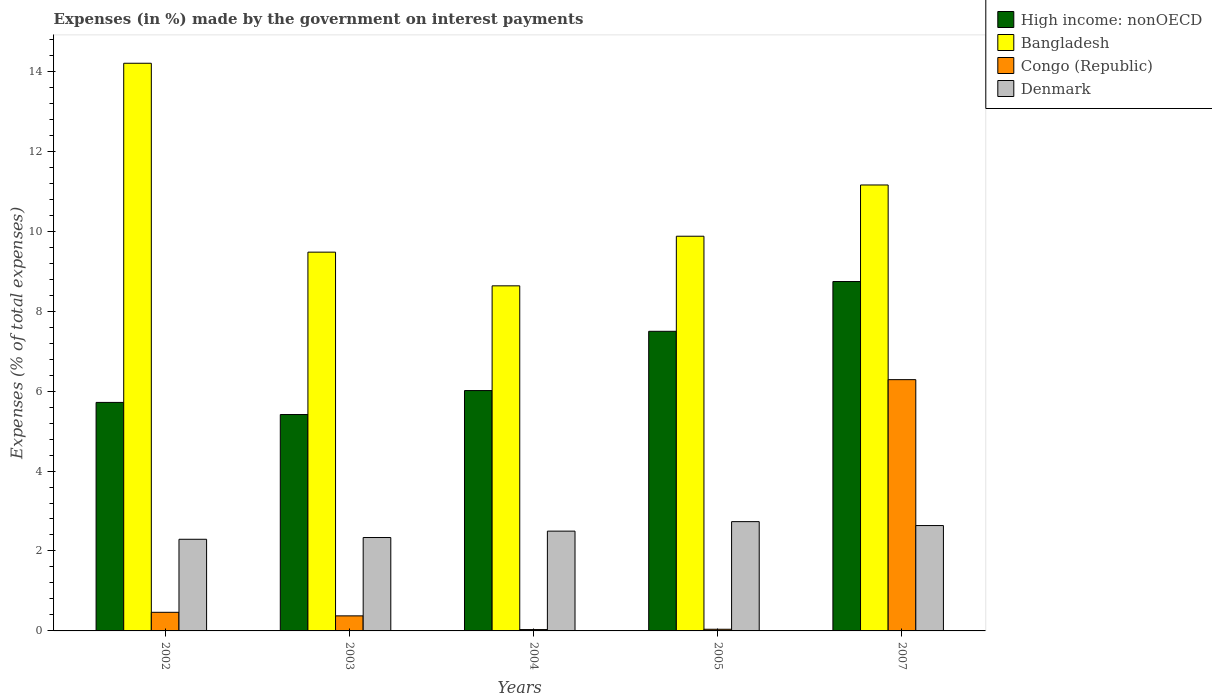How many different coloured bars are there?
Offer a terse response. 4. Are the number of bars on each tick of the X-axis equal?
Ensure brevity in your answer.  Yes. How many bars are there on the 3rd tick from the left?
Keep it short and to the point. 4. In how many cases, is the number of bars for a given year not equal to the number of legend labels?
Offer a terse response. 0. What is the percentage of expenses made by the government on interest payments in Bangladesh in 2007?
Offer a very short reply. 11.16. Across all years, what is the maximum percentage of expenses made by the government on interest payments in Denmark?
Keep it short and to the point. 2.73. Across all years, what is the minimum percentage of expenses made by the government on interest payments in Congo (Republic)?
Keep it short and to the point. 0.03. In which year was the percentage of expenses made by the government on interest payments in Congo (Republic) minimum?
Provide a succinct answer. 2004. What is the total percentage of expenses made by the government on interest payments in Bangladesh in the graph?
Keep it short and to the point. 53.34. What is the difference between the percentage of expenses made by the government on interest payments in High income: nonOECD in 2003 and that in 2007?
Make the answer very short. -3.33. What is the difference between the percentage of expenses made by the government on interest payments in Denmark in 2007 and the percentage of expenses made by the government on interest payments in High income: nonOECD in 2004?
Your answer should be compact. -3.38. What is the average percentage of expenses made by the government on interest payments in Bangladesh per year?
Give a very brief answer. 10.67. In the year 2005, what is the difference between the percentage of expenses made by the government on interest payments in Denmark and percentage of expenses made by the government on interest payments in Bangladesh?
Give a very brief answer. -7.14. What is the ratio of the percentage of expenses made by the government on interest payments in High income: nonOECD in 2004 to that in 2005?
Offer a very short reply. 0.8. Is the percentage of expenses made by the government on interest payments in High income: nonOECD in 2002 less than that in 2005?
Ensure brevity in your answer.  Yes. Is the difference between the percentage of expenses made by the government on interest payments in Denmark in 2005 and 2007 greater than the difference between the percentage of expenses made by the government on interest payments in Bangladesh in 2005 and 2007?
Provide a succinct answer. Yes. What is the difference between the highest and the second highest percentage of expenses made by the government on interest payments in Congo (Republic)?
Give a very brief answer. 5.82. What is the difference between the highest and the lowest percentage of expenses made by the government on interest payments in Denmark?
Ensure brevity in your answer.  0.44. In how many years, is the percentage of expenses made by the government on interest payments in Denmark greater than the average percentage of expenses made by the government on interest payments in Denmark taken over all years?
Offer a very short reply. 2. Is the sum of the percentage of expenses made by the government on interest payments in Bangladesh in 2002 and 2007 greater than the maximum percentage of expenses made by the government on interest payments in Denmark across all years?
Provide a short and direct response. Yes. What does the 3rd bar from the left in 2004 represents?
Offer a terse response. Congo (Republic). What does the 4th bar from the right in 2002 represents?
Your answer should be very brief. High income: nonOECD. What is the difference between two consecutive major ticks on the Y-axis?
Offer a very short reply. 2. Does the graph contain any zero values?
Give a very brief answer. No. Does the graph contain grids?
Your answer should be very brief. No. What is the title of the graph?
Offer a terse response. Expenses (in %) made by the government on interest payments. What is the label or title of the X-axis?
Give a very brief answer. Years. What is the label or title of the Y-axis?
Your response must be concise. Expenses (% of total expenses). What is the Expenses (% of total expenses) of High income: nonOECD in 2002?
Make the answer very short. 5.72. What is the Expenses (% of total expenses) in Bangladesh in 2002?
Keep it short and to the point. 14.2. What is the Expenses (% of total expenses) of Congo (Republic) in 2002?
Provide a short and direct response. 0.47. What is the Expenses (% of total expenses) in Denmark in 2002?
Provide a short and direct response. 2.29. What is the Expenses (% of total expenses) in High income: nonOECD in 2003?
Your response must be concise. 5.41. What is the Expenses (% of total expenses) of Bangladesh in 2003?
Offer a terse response. 9.48. What is the Expenses (% of total expenses) of Congo (Republic) in 2003?
Make the answer very short. 0.38. What is the Expenses (% of total expenses) in Denmark in 2003?
Ensure brevity in your answer.  2.34. What is the Expenses (% of total expenses) in High income: nonOECD in 2004?
Make the answer very short. 6.01. What is the Expenses (% of total expenses) of Bangladesh in 2004?
Ensure brevity in your answer.  8.63. What is the Expenses (% of total expenses) of Congo (Republic) in 2004?
Your answer should be very brief. 0.03. What is the Expenses (% of total expenses) of Denmark in 2004?
Your answer should be very brief. 2.5. What is the Expenses (% of total expenses) of High income: nonOECD in 2005?
Keep it short and to the point. 7.5. What is the Expenses (% of total expenses) of Bangladesh in 2005?
Your response must be concise. 9.87. What is the Expenses (% of total expenses) of Congo (Republic) in 2005?
Make the answer very short. 0.04. What is the Expenses (% of total expenses) in Denmark in 2005?
Offer a terse response. 2.73. What is the Expenses (% of total expenses) of High income: nonOECD in 2007?
Provide a succinct answer. 8.74. What is the Expenses (% of total expenses) in Bangladesh in 2007?
Offer a terse response. 11.16. What is the Expenses (% of total expenses) of Congo (Republic) in 2007?
Give a very brief answer. 6.29. What is the Expenses (% of total expenses) in Denmark in 2007?
Provide a succinct answer. 2.64. Across all years, what is the maximum Expenses (% of total expenses) of High income: nonOECD?
Your answer should be very brief. 8.74. Across all years, what is the maximum Expenses (% of total expenses) in Bangladesh?
Ensure brevity in your answer.  14.2. Across all years, what is the maximum Expenses (% of total expenses) of Congo (Republic)?
Keep it short and to the point. 6.29. Across all years, what is the maximum Expenses (% of total expenses) of Denmark?
Your answer should be compact. 2.73. Across all years, what is the minimum Expenses (% of total expenses) of High income: nonOECD?
Provide a short and direct response. 5.41. Across all years, what is the minimum Expenses (% of total expenses) in Bangladesh?
Provide a short and direct response. 8.63. Across all years, what is the minimum Expenses (% of total expenses) in Congo (Republic)?
Provide a short and direct response. 0.03. Across all years, what is the minimum Expenses (% of total expenses) of Denmark?
Your answer should be very brief. 2.29. What is the total Expenses (% of total expenses) of High income: nonOECD in the graph?
Your answer should be compact. 33.38. What is the total Expenses (% of total expenses) of Bangladesh in the graph?
Your response must be concise. 53.34. What is the total Expenses (% of total expenses) of Congo (Republic) in the graph?
Offer a terse response. 7.2. What is the total Expenses (% of total expenses) in Denmark in the graph?
Provide a short and direct response. 12.5. What is the difference between the Expenses (% of total expenses) in High income: nonOECD in 2002 and that in 2003?
Make the answer very short. 0.3. What is the difference between the Expenses (% of total expenses) in Bangladesh in 2002 and that in 2003?
Provide a succinct answer. 4.73. What is the difference between the Expenses (% of total expenses) of Congo (Republic) in 2002 and that in 2003?
Give a very brief answer. 0.09. What is the difference between the Expenses (% of total expenses) of Denmark in 2002 and that in 2003?
Your response must be concise. -0.04. What is the difference between the Expenses (% of total expenses) of High income: nonOECD in 2002 and that in 2004?
Provide a short and direct response. -0.3. What is the difference between the Expenses (% of total expenses) in Bangladesh in 2002 and that in 2004?
Provide a succinct answer. 5.57. What is the difference between the Expenses (% of total expenses) in Congo (Republic) in 2002 and that in 2004?
Give a very brief answer. 0.43. What is the difference between the Expenses (% of total expenses) in Denmark in 2002 and that in 2004?
Offer a terse response. -0.2. What is the difference between the Expenses (% of total expenses) of High income: nonOECD in 2002 and that in 2005?
Keep it short and to the point. -1.78. What is the difference between the Expenses (% of total expenses) in Bangladesh in 2002 and that in 2005?
Make the answer very short. 4.33. What is the difference between the Expenses (% of total expenses) of Congo (Republic) in 2002 and that in 2005?
Keep it short and to the point. 0.42. What is the difference between the Expenses (% of total expenses) of Denmark in 2002 and that in 2005?
Provide a short and direct response. -0.44. What is the difference between the Expenses (% of total expenses) in High income: nonOECD in 2002 and that in 2007?
Your answer should be compact. -3.02. What is the difference between the Expenses (% of total expenses) of Bangladesh in 2002 and that in 2007?
Provide a succinct answer. 3.04. What is the difference between the Expenses (% of total expenses) of Congo (Republic) in 2002 and that in 2007?
Keep it short and to the point. -5.82. What is the difference between the Expenses (% of total expenses) of Denmark in 2002 and that in 2007?
Make the answer very short. -0.34. What is the difference between the Expenses (% of total expenses) in High income: nonOECD in 2003 and that in 2004?
Your answer should be very brief. -0.6. What is the difference between the Expenses (% of total expenses) in Bangladesh in 2003 and that in 2004?
Make the answer very short. 0.84. What is the difference between the Expenses (% of total expenses) in Congo (Republic) in 2003 and that in 2004?
Your answer should be very brief. 0.34. What is the difference between the Expenses (% of total expenses) in Denmark in 2003 and that in 2004?
Give a very brief answer. -0.16. What is the difference between the Expenses (% of total expenses) of High income: nonOECD in 2003 and that in 2005?
Your response must be concise. -2.08. What is the difference between the Expenses (% of total expenses) of Bangladesh in 2003 and that in 2005?
Provide a succinct answer. -0.4. What is the difference between the Expenses (% of total expenses) of Congo (Republic) in 2003 and that in 2005?
Provide a short and direct response. 0.33. What is the difference between the Expenses (% of total expenses) of Denmark in 2003 and that in 2005?
Make the answer very short. -0.4. What is the difference between the Expenses (% of total expenses) in High income: nonOECD in 2003 and that in 2007?
Offer a very short reply. -3.33. What is the difference between the Expenses (% of total expenses) of Bangladesh in 2003 and that in 2007?
Your answer should be very brief. -1.68. What is the difference between the Expenses (% of total expenses) in Congo (Republic) in 2003 and that in 2007?
Provide a succinct answer. -5.91. What is the difference between the Expenses (% of total expenses) of Denmark in 2003 and that in 2007?
Keep it short and to the point. -0.3. What is the difference between the Expenses (% of total expenses) in High income: nonOECD in 2004 and that in 2005?
Provide a succinct answer. -1.48. What is the difference between the Expenses (% of total expenses) in Bangladesh in 2004 and that in 2005?
Keep it short and to the point. -1.24. What is the difference between the Expenses (% of total expenses) of Congo (Republic) in 2004 and that in 2005?
Provide a succinct answer. -0.01. What is the difference between the Expenses (% of total expenses) in Denmark in 2004 and that in 2005?
Your answer should be compact. -0.24. What is the difference between the Expenses (% of total expenses) of High income: nonOECD in 2004 and that in 2007?
Your answer should be compact. -2.73. What is the difference between the Expenses (% of total expenses) of Bangladesh in 2004 and that in 2007?
Your response must be concise. -2.52. What is the difference between the Expenses (% of total expenses) in Congo (Republic) in 2004 and that in 2007?
Make the answer very short. -6.25. What is the difference between the Expenses (% of total expenses) of Denmark in 2004 and that in 2007?
Your answer should be compact. -0.14. What is the difference between the Expenses (% of total expenses) in High income: nonOECD in 2005 and that in 2007?
Your answer should be very brief. -1.25. What is the difference between the Expenses (% of total expenses) in Bangladesh in 2005 and that in 2007?
Your answer should be very brief. -1.28. What is the difference between the Expenses (% of total expenses) in Congo (Republic) in 2005 and that in 2007?
Provide a short and direct response. -6.24. What is the difference between the Expenses (% of total expenses) of Denmark in 2005 and that in 2007?
Your response must be concise. 0.1. What is the difference between the Expenses (% of total expenses) of High income: nonOECD in 2002 and the Expenses (% of total expenses) of Bangladesh in 2003?
Keep it short and to the point. -3.76. What is the difference between the Expenses (% of total expenses) of High income: nonOECD in 2002 and the Expenses (% of total expenses) of Congo (Republic) in 2003?
Provide a short and direct response. 5.34. What is the difference between the Expenses (% of total expenses) in High income: nonOECD in 2002 and the Expenses (% of total expenses) in Denmark in 2003?
Provide a succinct answer. 3.38. What is the difference between the Expenses (% of total expenses) of Bangladesh in 2002 and the Expenses (% of total expenses) of Congo (Republic) in 2003?
Ensure brevity in your answer.  13.82. What is the difference between the Expenses (% of total expenses) in Bangladesh in 2002 and the Expenses (% of total expenses) in Denmark in 2003?
Offer a terse response. 11.86. What is the difference between the Expenses (% of total expenses) in Congo (Republic) in 2002 and the Expenses (% of total expenses) in Denmark in 2003?
Make the answer very short. -1.87. What is the difference between the Expenses (% of total expenses) of High income: nonOECD in 2002 and the Expenses (% of total expenses) of Bangladesh in 2004?
Your response must be concise. -2.92. What is the difference between the Expenses (% of total expenses) of High income: nonOECD in 2002 and the Expenses (% of total expenses) of Congo (Republic) in 2004?
Provide a short and direct response. 5.68. What is the difference between the Expenses (% of total expenses) of High income: nonOECD in 2002 and the Expenses (% of total expenses) of Denmark in 2004?
Offer a very short reply. 3.22. What is the difference between the Expenses (% of total expenses) in Bangladesh in 2002 and the Expenses (% of total expenses) in Congo (Republic) in 2004?
Provide a succinct answer. 14.17. What is the difference between the Expenses (% of total expenses) in Bangladesh in 2002 and the Expenses (% of total expenses) in Denmark in 2004?
Your response must be concise. 11.7. What is the difference between the Expenses (% of total expenses) in Congo (Republic) in 2002 and the Expenses (% of total expenses) in Denmark in 2004?
Provide a succinct answer. -2.03. What is the difference between the Expenses (% of total expenses) of High income: nonOECD in 2002 and the Expenses (% of total expenses) of Bangladesh in 2005?
Give a very brief answer. -4.16. What is the difference between the Expenses (% of total expenses) of High income: nonOECD in 2002 and the Expenses (% of total expenses) of Congo (Republic) in 2005?
Your answer should be very brief. 5.67. What is the difference between the Expenses (% of total expenses) of High income: nonOECD in 2002 and the Expenses (% of total expenses) of Denmark in 2005?
Provide a short and direct response. 2.98. What is the difference between the Expenses (% of total expenses) in Bangladesh in 2002 and the Expenses (% of total expenses) in Congo (Republic) in 2005?
Your answer should be compact. 14.16. What is the difference between the Expenses (% of total expenses) of Bangladesh in 2002 and the Expenses (% of total expenses) of Denmark in 2005?
Provide a succinct answer. 11.47. What is the difference between the Expenses (% of total expenses) in Congo (Republic) in 2002 and the Expenses (% of total expenses) in Denmark in 2005?
Provide a short and direct response. -2.27. What is the difference between the Expenses (% of total expenses) in High income: nonOECD in 2002 and the Expenses (% of total expenses) in Bangladesh in 2007?
Make the answer very short. -5.44. What is the difference between the Expenses (% of total expenses) of High income: nonOECD in 2002 and the Expenses (% of total expenses) of Congo (Republic) in 2007?
Make the answer very short. -0.57. What is the difference between the Expenses (% of total expenses) of High income: nonOECD in 2002 and the Expenses (% of total expenses) of Denmark in 2007?
Keep it short and to the point. 3.08. What is the difference between the Expenses (% of total expenses) of Bangladesh in 2002 and the Expenses (% of total expenses) of Congo (Republic) in 2007?
Keep it short and to the point. 7.91. What is the difference between the Expenses (% of total expenses) in Bangladesh in 2002 and the Expenses (% of total expenses) in Denmark in 2007?
Your answer should be compact. 11.56. What is the difference between the Expenses (% of total expenses) in Congo (Republic) in 2002 and the Expenses (% of total expenses) in Denmark in 2007?
Keep it short and to the point. -2.17. What is the difference between the Expenses (% of total expenses) in High income: nonOECD in 2003 and the Expenses (% of total expenses) in Bangladesh in 2004?
Make the answer very short. -3.22. What is the difference between the Expenses (% of total expenses) of High income: nonOECD in 2003 and the Expenses (% of total expenses) of Congo (Republic) in 2004?
Your answer should be very brief. 5.38. What is the difference between the Expenses (% of total expenses) in High income: nonOECD in 2003 and the Expenses (% of total expenses) in Denmark in 2004?
Keep it short and to the point. 2.92. What is the difference between the Expenses (% of total expenses) in Bangladesh in 2003 and the Expenses (% of total expenses) in Congo (Republic) in 2004?
Provide a succinct answer. 9.44. What is the difference between the Expenses (% of total expenses) of Bangladesh in 2003 and the Expenses (% of total expenses) of Denmark in 2004?
Give a very brief answer. 6.98. What is the difference between the Expenses (% of total expenses) in Congo (Republic) in 2003 and the Expenses (% of total expenses) in Denmark in 2004?
Give a very brief answer. -2.12. What is the difference between the Expenses (% of total expenses) in High income: nonOECD in 2003 and the Expenses (% of total expenses) in Bangladesh in 2005?
Your answer should be compact. -4.46. What is the difference between the Expenses (% of total expenses) in High income: nonOECD in 2003 and the Expenses (% of total expenses) in Congo (Republic) in 2005?
Offer a very short reply. 5.37. What is the difference between the Expenses (% of total expenses) in High income: nonOECD in 2003 and the Expenses (% of total expenses) in Denmark in 2005?
Offer a terse response. 2.68. What is the difference between the Expenses (% of total expenses) of Bangladesh in 2003 and the Expenses (% of total expenses) of Congo (Republic) in 2005?
Provide a short and direct response. 9.43. What is the difference between the Expenses (% of total expenses) in Bangladesh in 2003 and the Expenses (% of total expenses) in Denmark in 2005?
Offer a terse response. 6.74. What is the difference between the Expenses (% of total expenses) of Congo (Republic) in 2003 and the Expenses (% of total expenses) of Denmark in 2005?
Offer a terse response. -2.36. What is the difference between the Expenses (% of total expenses) of High income: nonOECD in 2003 and the Expenses (% of total expenses) of Bangladesh in 2007?
Give a very brief answer. -5.74. What is the difference between the Expenses (% of total expenses) of High income: nonOECD in 2003 and the Expenses (% of total expenses) of Congo (Republic) in 2007?
Keep it short and to the point. -0.87. What is the difference between the Expenses (% of total expenses) in High income: nonOECD in 2003 and the Expenses (% of total expenses) in Denmark in 2007?
Your answer should be very brief. 2.78. What is the difference between the Expenses (% of total expenses) of Bangladesh in 2003 and the Expenses (% of total expenses) of Congo (Republic) in 2007?
Your answer should be very brief. 3.19. What is the difference between the Expenses (% of total expenses) in Bangladesh in 2003 and the Expenses (% of total expenses) in Denmark in 2007?
Ensure brevity in your answer.  6.84. What is the difference between the Expenses (% of total expenses) in Congo (Republic) in 2003 and the Expenses (% of total expenses) in Denmark in 2007?
Provide a short and direct response. -2.26. What is the difference between the Expenses (% of total expenses) in High income: nonOECD in 2004 and the Expenses (% of total expenses) in Bangladesh in 2005?
Your answer should be compact. -3.86. What is the difference between the Expenses (% of total expenses) in High income: nonOECD in 2004 and the Expenses (% of total expenses) in Congo (Republic) in 2005?
Your response must be concise. 5.97. What is the difference between the Expenses (% of total expenses) of High income: nonOECD in 2004 and the Expenses (% of total expenses) of Denmark in 2005?
Your response must be concise. 3.28. What is the difference between the Expenses (% of total expenses) in Bangladesh in 2004 and the Expenses (% of total expenses) in Congo (Republic) in 2005?
Ensure brevity in your answer.  8.59. What is the difference between the Expenses (% of total expenses) in Bangladesh in 2004 and the Expenses (% of total expenses) in Denmark in 2005?
Your answer should be compact. 5.9. What is the difference between the Expenses (% of total expenses) in Congo (Republic) in 2004 and the Expenses (% of total expenses) in Denmark in 2005?
Keep it short and to the point. -2.7. What is the difference between the Expenses (% of total expenses) in High income: nonOECD in 2004 and the Expenses (% of total expenses) in Bangladesh in 2007?
Ensure brevity in your answer.  -5.14. What is the difference between the Expenses (% of total expenses) of High income: nonOECD in 2004 and the Expenses (% of total expenses) of Congo (Republic) in 2007?
Offer a very short reply. -0.27. What is the difference between the Expenses (% of total expenses) in High income: nonOECD in 2004 and the Expenses (% of total expenses) in Denmark in 2007?
Your response must be concise. 3.38. What is the difference between the Expenses (% of total expenses) in Bangladesh in 2004 and the Expenses (% of total expenses) in Congo (Republic) in 2007?
Keep it short and to the point. 2.35. What is the difference between the Expenses (% of total expenses) of Bangladesh in 2004 and the Expenses (% of total expenses) of Denmark in 2007?
Provide a short and direct response. 6. What is the difference between the Expenses (% of total expenses) in Congo (Republic) in 2004 and the Expenses (% of total expenses) in Denmark in 2007?
Provide a succinct answer. -2.6. What is the difference between the Expenses (% of total expenses) of High income: nonOECD in 2005 and the Expenses (% of total expenses) of Bangladesh in 2007?
Your answer should be very brief. -3.66. What is the difference between the Expenses (% of total expenses) in High income: nonOECD in 2005 and the Expenses (% of total expenses) in Congo (Republic) in 2007?
Provide a succinct answer. 1.21. What is the difference between the Expenses (% of total expenses) in High income: nonOECD in 2005 and the Expenses (% of total expenses) in Denmark in 2007?
Ensure brevity in your answer.  4.86. What is the difference between the Expenses (% of total expenses) in Bangladesh in 2005 and the Expenses (% of total expenses) in Congo (Republic) in 2007?
Give a very brief answer. 3.59. What is the difference between the Expenses (% of total expenses) in Bangladesh in 2005 and the Expenses (% of total expenses) in Denmark in 2007?
Provide a succinct answer. 7.24. What is the difference between the Expenses (% of total expenses) of Congo (Republic) in 2005 and the Expenses (% of total expenses) of Denmark in 2007?
Your answer should be very brief. -2.59. What is the average Expenses (% of total expenses) in High income: nonOECD per year?
Provide a short and direct response. 6.68. What is the average Expenses (% of total expenses) in Bangladesh per year?
Offer a very short reply. 10.67. What is the average Expenses (% of total expenses) of Congo (Republic) per year?
Make the answer very short. 1.44. What is the average Expenses (% of total expenses) of Denmark per year?
Offer a terse response. 2.5. In the year 2002, what is the difference between the Expenses (% of total expenses) in High income: nonOECD and Expenses (% of total expenses) in Bangladesh?
Offer a terse response. -8.48. In the year 2002, what is the difference between the Expenses (% of total expenses) in High income: nonOECD and Expenses (% of total expenses) in Congo (Republic)?
Offer a very short reply. 5.25. In the year 2002, what is the difference between the Expenses (% of total expenses) of High income: nonOECD and Expenses (% of total expenses) of Denmark?
Keep it short and to the point. 3.42. In the year 2002, what is the difference between the Expenses (% of total expenses) of Bangladesh and Expenses (% of total expenses) of Congo (Republic)?
Your response must be concise. 13.73. In the year 2002, what is the difference between the Expenses (% of total expenses) in Bangladesh and Expenses (% of total expenses) in Denmark?
Provide a succinct answer. 11.91. In the year 2002, what is the difference between the Expenses (% of total expenses) in Congo (Republic) and Expenses (% of total expenses) in Denmark?
Your response must be concise. -1.83. In the year 2003, what is the difference between the Expenses (% of total expenses) of High income: nonOECD and Expenses (% of total expenses) of Bangladesh?
Provide a succinct answer. -4.06. In the year 2003, what is the difference between the Expenses (% of total expenses) in High income: nonOECD and Expenses (% of total expenses) in Congo (Republic)?
Ensure brevity in your answer.  5.04. In the year 2003, what is the difference between the Expenses (% of total expenses) of High income: nonOECD and Expenses (% of total expenses) of Denmark?
Provide a short and direct response. 3.08. In the year 2003, what is the difference between the Expenses (% of total expenses) in Bangladesh and Expenses (% of total expenses) in Congo (Republic)?
Your response must be concise. 9.1. In the year 2003, what is the difference between the Expenses (% of total expenses) of Bangladesh and Expenses (% of total expenses) of Denmark?
Give a very brief answer. 7.14. In the year 2003, what is the difference between the Expenses (% of total expenses) of Congo (Republic) and Expenses (% of total expenses) of Denmark?
Provide a short and direct response. -1.96. In the year 2004, what is the difference between the Expenses (% of total expenses) of High income: nonOECD and Expenses (% of total expenses) of Bangladesh?
Your answer should be compact. -2.62. In the year 2004, what is the difference between the Expenses (% of total expenses) in High income: nonOECD and Expenses (% of total expenses) in Congo (Republic)?
Offer a terse response. 5.98. In the year 2004, what is the difference between the Expenses (% of total expenses) in High income: nonOECD and Expenses (% of total expenses) in Denmark?
Make the answer very short. 3.52. In the year 2004, what is the difference between the Expenses (% of total expenses) of Bangladesh and Expenses (% of total expenses) of Congo (Republic)?
Offer a very short reply. 8.6. In the year 2004, what is the difference between the Expenses (% of total expenses) of Bangladesh and Expenses (% of total expenses) of Denmark?
Keep it short and to the point. 6.14. In the year 2004, what is the difference between the Expenses (% of total expenses) of Congo (Republic) and Expenses (% of total expenses) of Denmark?
Your response must be concise. -2.46. In the year 2005, what is the difference between the Expenses (% of total expenses) of High income: nonOECD and Expenses (% of total expenses) of Bangladesh?
Keep it short and to the point. -2.38. In the year 2005, what is the difference between the Expenses (% of total expenses) of High income: nonOECD and Expenses (% of total expenses) of Congo (Republic)?
Your answer should be compact. 7.45. In the year 2005, what is the difference between the Expenses (% of total expenses) in High income: nonOECD and Expenses (% of total expenses) in Denmark?
Offer a terse response. 4.76. In the year 2005, what is the difference between the Expenses (% of total expenses) of Bangladesh and Expenses (% of total expenses) of Congo (Republic)?
Your answer should be compact. 9.83. In the year 2005, what is the difference between the Expenses (% of total expenses) of Bangladesh and Expenses (% of total expenses) of Denmark?
Offer a terse response. 7.14. In the year 2005, what is the difference between the Expenses (% of total expenses) in Congo (Republic) and Expenses (% of total expenses) in Denmark?
Ensure brevity in your answer.  -2.69. In the year 2007, what is the difference between the Expenses (% of total expenses) of High income: nonOECD and Expenses (% of total expenses) of Bangladesh?
Ensure brevity in your answer.  -2.42. In the year 2007, what is the difference between the Expenses (% of total expenses) in High income: nonOECD and Expenses (% of total expenses) in Congo (Republic)?
Keep it short and to the point. 2.45. In the year 2007, what is the difference between the Expenses (% of total expenses) of High income: nonOECD and Expenses (% of total expenses) of Denmark?
Offer a terse response. 6.1. In the year 2007, what is the difference between the Expenses (% of total expenses) of Bangladesh and Expenses (% of total expenses) of Congo (Republic)?
Offer a very short reply. 4.87. In the year 2007, what is the difference between the Expenses (% of total expenses) in Bangladesh and Expenses (% of total expenses) in Denmark?
Your answer should be very brief. 8.52. In the year 2007, what is the difference between the Expenses (% of total expenses) in Congo (Republic) and Expenses (% of total expenses) in Denmark?
Your response must be concise. 3.65. What is the ratio of the Expenses (% of total expenses) of High income: nonOECD in 2002 to that in 2003?
Make the answer very short. 1.06. What is the ratio of the Expenses (% of total expenses) of Bangladesh in 2002 to that in 2003?
Keep it short and to the point. 1.5. What is the ratio of the Expenses (% of total expenses) of Congo (Republic) in 2002 to that in 2003?
Offer a very short reply. 1.24. What is the ratio of the Expenses (% of total expenses) in Denmark in 2002 to that in 2003?
Provide a succinct answer. 0.98. What is the ratio of the Expenses (% of total expenses) in High income: nonOECD in 2002 to that in 2004?
Provide a succinct answer. 0.95. What is the ratio of the Expenses (% of total expenses) of Bangladesh in 2002 to that in 2004?
Provide a short and direct response. 1.65. What is the ratio of the Expenses (% of total expenses) in Congo (Republic) in 2002 to that in 2004?
Keep it short and to the point. 13.75. What is the ratio of the Expenses (% of total expenses) of Denmark in 2002 to that in 2004?
Make the answer very short. 0.92. What is the ratio of the Expenses (% of total expenses) of High income: nonOECD in 2002 to that in 2005?
Make the answer very short. 0.76. What is the ratio of the Expenses (% of total expenses) in Bangladesh in 2002 to that in 2005?
Provide a short and direct response. 1.44. What is the ratio of the Expenses (% of total expenses) of Congo (Republic) in 2002 to that in 2005?
Give a very brief answer. 11.15. What is the ratio of the Expenses (% of total expenses) in Denmark in 2002 to that in 2005?
Your response must be concise. 0.84. What is the ratio of the Expenses (% of total expenses) of High income: nonOECD in 2002 to that in 2007?
Ensure brevity in your answer.  0.65. What is the ratio of the Expenses (% of total expenses) in Bangladesh in 2002 to that in 2007?
Offer a very short reply. 1.27. What is the ratio of the Expenses (% of total expenses) of Congo (Republic) in 2002 to that in 2007?
Provide a short and direct response. 0.07. What is the ratio of the Expenses (% of total expenses) in Denmark in 2002 to that in 2007?
Your answer should be very brief. 0.87. What is the ratio of the Expenses (% of total expenses) in High income: nonOECD in 2003 to that in 2004?
Make the answer very short. 0.9. What is the ratio of the Expenses (% of total expenses) of Bangladesh in 2003 to that in 2004?
Keep it short and to the point. 1.1. What is the ratio of the Expenses (% of total expenses) of Congo (Republic) in 2003 to that in 2004?
Provide a short and direct response. 11.12. What is the ratio of the Expenses (% of total expenses) of Denmark in 2003 to that in 2004?
Give a very brief answer. 0.94. What is the ratio of the Expenses (% of total expenses) in High income: nonOECD in 2003 to that in 2005?
Ensure brevity in your answer.  0.72. What is the ratio of the Expenses (% of total expenses) of Bangladesh in 2003 to that in 2005?
Make the answer very short. 0.96. What is the ratio of the Expenses (% of total expenses) of Congo (Republic) in 2003 to that in 2005?
Offer a terse response. 9.02. What is the ratio of the Expenses (% of total expenses) in Denmark in 2003 to that in 2005?
Your answer should be very brief. 0.85. What is the ratio of the Expenses (% of total expenses) in High income: nonOECD in 2003 to that in 2007?
Your answer should be very brief. 0.62. What is the ratio of the Expenses (% of total expenses) of Bangladesh in 2003 to that in 2007?
Your answer should be compact. 0.85. What is the ratio of the Expenses (% of total expenses) of Congo (Republic) in 2003 to that in 2007?
Offer a very short reply. 0.06. What is the ratio of the Expenses (% of total expenses) of Denmark in 2003 to that in 2007?
Offer a very short reply. 0.89. What is the ratio of the Expenses (% of total expenses) in High income: nonOECD in 2004 to that in 2005?
Provide a short and direct response. 0.8. What is the ratio of the Expenses (% of total expenses) of Bangladesh in 2004 to that in 2005?
Your response must be concise. 0.87. What is the ratio of the Expenses (% of total expenses) of Congo (Republic) in 2004 to that in 2005?
Provide a succinct answer. 0.81. What is the ratio of the Expenses (% of total expenses) in Denmark in 2004 to that in 2005?
Keep it short and to the point. 0.91. What is the ratio of the Expenses (% of total expenses) in High income: nonOECD in 2004 to that in 2007?
Offer a very short reply. 0.69. What is the ratio of the Expenses (% of total expenses) in Bangladesh in 2004 to that in 2007?
Your response must be concise. 0.77. What is the ratio of the Expenses (% of total expenses) in Congo (Republic) in 2004 to that in 2007?
Keep it short and to the point. 0.01. What is the ratio of the Expenses (% of total expenses) in Denmark in 2004 to that in 2007?
Keep it short and to the point. 0.95. What is the ratio of the Expenses (% of total expenses) of High income: nonOECD in 2005 to that in 2007?
Make the answer very short. 0.86. What is the ratio of the Expenses (% of total expenses) in Bangladesh in 2005 to that in 2007?
Your answer should be compact. 0.89. What is the ratio of the Expenses (% of total expenses) in Congo (Republic) in 2005 to that in 2007?
Provide a succinct answer. 0.01. What is the ratio of the Expenses (% of total expenses) in Denmark in 2005 to that in 2007?
Make the answer very short. 1.04. What is the difference between the highest and the second highest Expenses (% of total expenses) in High income: nonOECD?
Your answer should be very brief. 1.25. What is the difference between the highest and the second highest Expenses (% of total expenses) in Bangladesh?
Your answer should be very brief. 3.04. What is the difference between the highest and the second highest Expenses (% of total expenses) of Congo (Republic)?
Your answer should be compact. 5.82. What is the difference between the highest and the second highest Expenses (% of total expenses) in Denmark?
Offer a terse response. 0.1. What is the difference between the highest and the lowest Expenses (% of total expenses) of High income: nonOECD?
Offer a very short reply. 3.33. What is the difference between the highest and the lowest Expenses (% of total expenses) of Bangladesh?
Ensure brevity in your answer.  5.57. What is the difference between the highest and the lowest Expenses (% of total expenses) of Congo (Republic)?
Give a very brief answer. 6.25. What is the difference between the highest and the lowest Expenses (% of total expenses) in Denmark?
Keep it short and to the point. 0.44. 